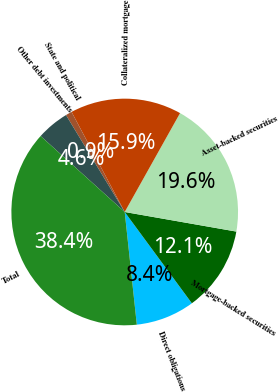Convert chart. <chart><loc_0><loc_0><loc_500><loc_500><pie_chart><fcel>Direct obligations<fcel>Mortgage-backed securities<fcel>Asset-backed securities<fcel>Collateralized mortgage<fcel>State and political<fcel>Other debt investments<fcel>Total<nl><fcel>8.39%<fcel>12.14%<fcel>19.64%<fcel>15.89%<fcel>0.9%<fcel>4.64%<fcel>38.39%<nl></chart> 